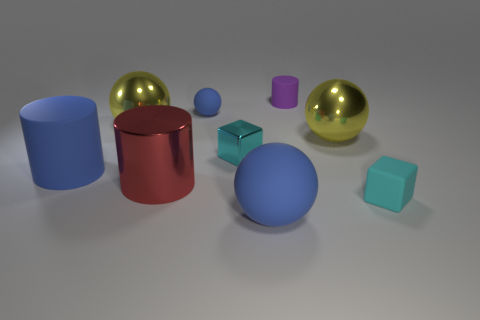Is the number of big matte objects right of the big red object the same as the number of yellow metal spheres behind the big rubber cylinder?
Offer a very short reply. No. Is the cyan block behind the matte cube made of the same material as the large yellow sphere right of the big red metal cylinder?
Offer a very short reply. Yes. What number of other objects are there of the same size as the blue matte cylinder?
Your answer should be very brief. 4. What number of things are big brown matte cylinders or small things in front of the small rubber cylinder?
Your answer should be compact. 3. Is the number of large matte things that are right of the tiny rubber cylinder the same as the number of big brown balls?
Provide a succinct answer. Yes. What is the shape of the cyan object that is the same material as the tiny blue object?
Offer a terse response. Cube. Is there a tiny thing of the same color as the tiny metal cube?
Your answer should be compact. Yes. What number of shiny things are large brown blocks or blue objects?
Keep it short and to the point. 0. How many small cyan matte cubes are left of the tiny matte object that is in front of the metallic cylinder?
Offer a very short reply. 0. How many big blue objects are made of the same material as the tiny ball?
Offer a very short reply. 2. 